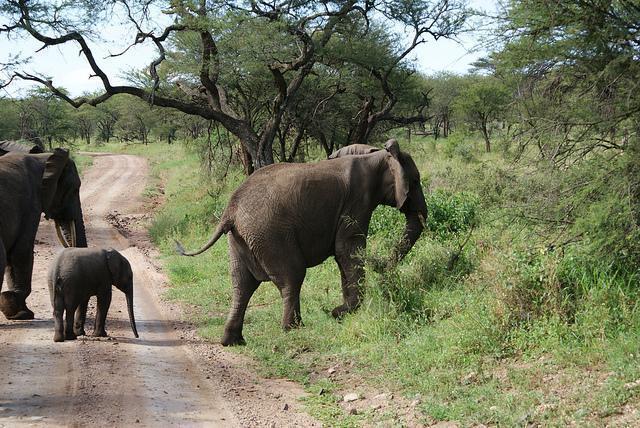How many elephants are standing right on the dirt road to the left?
Indicate the correct response and explain using: 'Answer: answer
Rationale: rationale.'
Options: Five, four, three, two. Answer: two.
Rationale: An adult with a baby stands on the road while another elephant walks off to the side. 